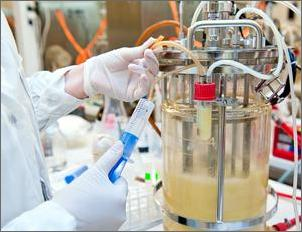Which of the following could Emilia's test show? whether she added enough nutrients to help the bacteria produce 20% more insulin why? People can use the engineering-design process to develop solutions to problems. One step in the process is testing if a potential solution meets the requirements of the design. How can you determine what a test can show? You need to figure out what was tested and what was measured.
Imagine an engineer needs to design a bridge for a windy location. She wants to make sure the bridge will not move too much in high wind. So, she builds a smaller prototype, or model, of a bridge. Then, she exposes the prototype to high winds and measures how much the bridge moves.
First, identify what was tested. A test can examine one design, or it may compare multiple prototypes to each other. In the test described above, the engineer tested a prototype of a bridge in high wind.
Then, identify what the test measured. One of the criteria for the bridge was that it not move too much in high winds. The test measured how much the prototype bridge moved.
Tests can show how well one or more designs meet the criteria. The test described above can show whether the bridge would move too much in high winds.  